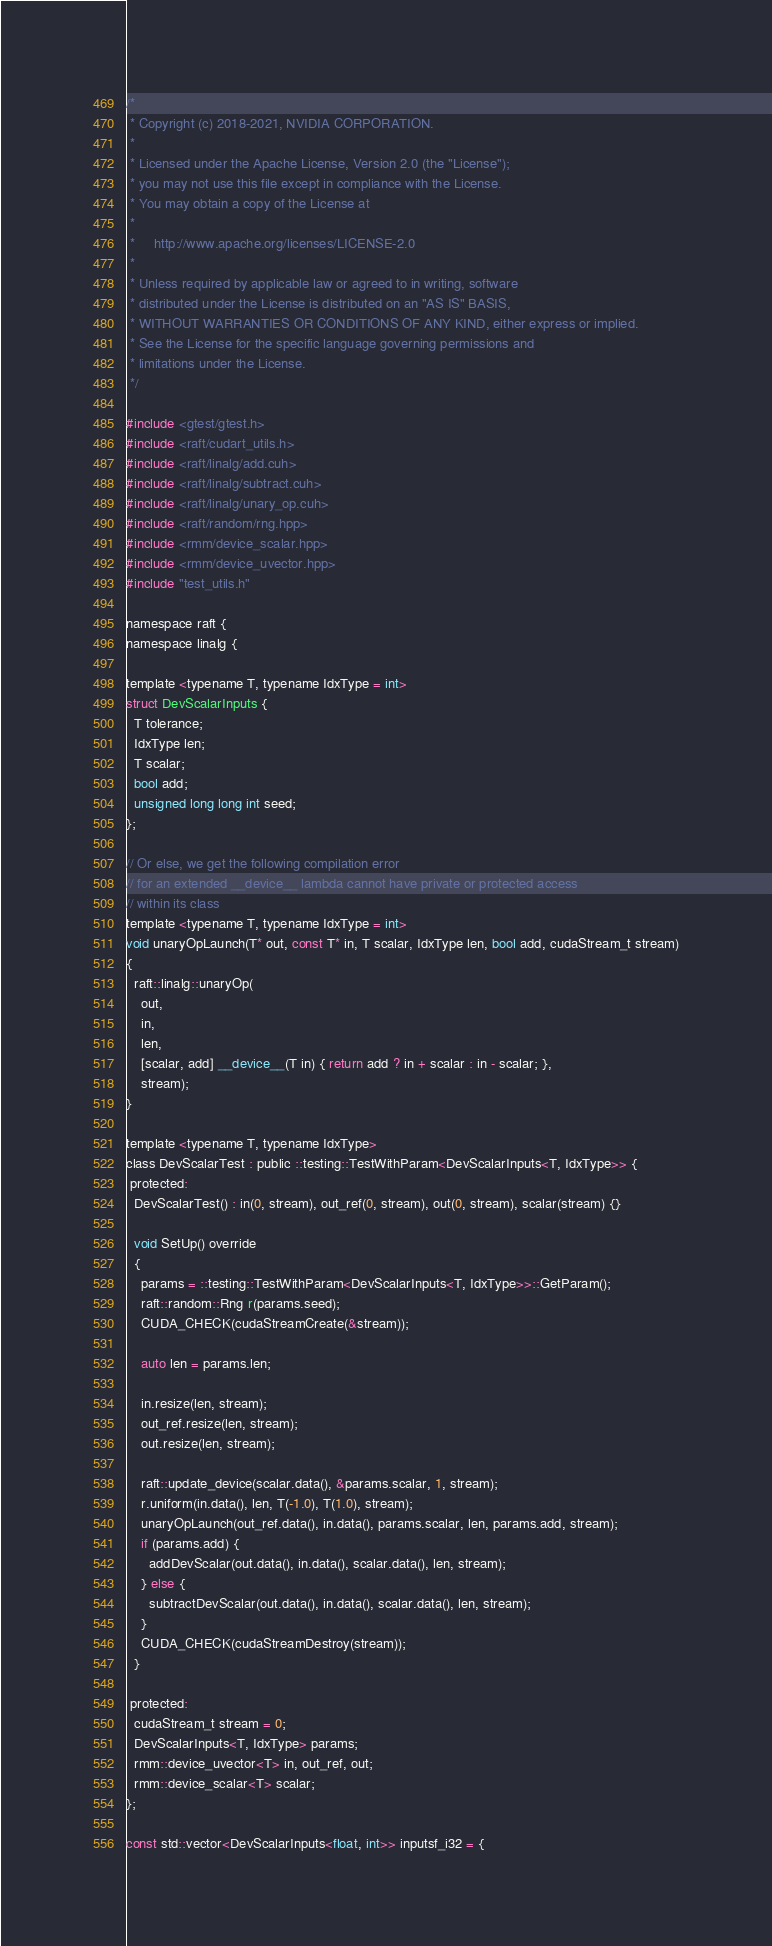<code> <loc_0><loc_0><loc_500><loc_500><_Cuda_>/*
 * Copyright (c) 2018-2021, NVIDIA CORPORATION.
 *
 * Licensed under the Apache License, Version 2.0 (the "License");
 * you may not use this file except in compliance with the License.
 * You may obtain a copy of the License at
 *
 *     http://www.apache.org/licenses/LICENSE-2.0
 *
 * Unless required by applicable law or agreed to in writing, software
 * distributed under the License is distributed on an "AS IS" BASIS,
 * WITHOUT WARRANTIES OR CONDITIONS OF ANY KIND, either express or implied.
 * See the License for the specific language governing permissions and
 * limitations under the License.
 */

#include <gtest/gtest.h>
#include <raft/cudart_utils.h>
#include <raft/linalg/add.cuh>
#include <raft/linalg/subtract.cuh>
#include <raft/linalg/unary_op.cuh>
#include <raft/random/rng.hpp>
#include <rmm/device_scalar.hpp>
#include <rmm/device_uvector.hpp>
#include "test_utils.h"

namespace raft {
namespace linalg {

template <typename T, typename IdxType = int>
struct DevScalarInputs {
  T tolerance;
  IdxType len;
  T scalar;
  bool add;
  unsigned long long int seed;
};

// Or else, we get the following compilation error
// for an extended __device__ lambda cannot have private or protected access
// within its class
template <typename T, typename IdxType = int>
void unaryOpLaunch(T* out, const T* in, T scalar, IdxType len, bool add, cudaStream_t stream)
{
  raft::linalg::unaryOp(
    out,
    in,
    len,
    [scalar, add] __device__(T in) { return add ? in + scalar : in - scalar; },
    stream);
}

template <typename T, typename IdxType>
class DevScalarTest : public ::testing::TestWithParam<DevScalarInputs<T, IdxType>> {
 protected:
  DevScalarTest() : in(0, stream), out_ref(0, stream), out(0, stream), scalar(stream) {}

  void SetUp() override
  {
    params = ::testing::TestWithParam<DevScalarInputs<T, IdxType>>::GetParam();
    raft::random::Rng r(params.seed);
    CUDA_CHECK(cudaStreamCreate(&stream));

    auto len = params.len;

    in.resize(len, stream);
    out_ref.resize(len, stream);
    out.resize(len, stream);

    raft::update_device(scalar.data(), &params.scalar, 1, stream);
    r.uniform(in.data(), len, T(-1.0), T(1.0), stream);
    unaryOpLaunch(out_ref.data(), in.data(), params.scalar, len, params.add, stream);
    if (params.add) {
      addDevScalar(out.data(), in.data(), scalar.data(), len, stream);
    } else {
      subtractDevScalar(out.data(), in.data(), scalar.data(), len, stream);
    }
    CUDA_CHECK(cudaStreamDestroy(stream));
  }

 protected:
  cudaStream_t stream = 0;
  DevScalarInputs<T, IdxType> params;
  rmm::device_uvector<T> in, out_ref, out;
  rmm::device_scalar<T> scalar;
};

const std::vector<DevScalarInputs<float, int>> inputsf_i32 = {</code> 